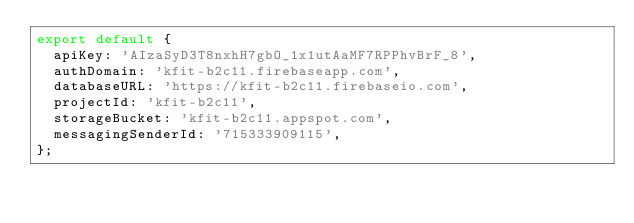<code> <loc_0><loc_0><loc_500><loc_500><_JavaScript_>export default {
  apiKey: 'AIzaSyD3T8nxhH7gbO_1x1utAaMF7RPPhvBrF_8',
  authDomain: 'kfit-b2c11.firebaseapp.com',
  databaseURL: 'https://kfit-b2c11.firebaseio.com',
  projectId: 'kfit-b2c11',
  storageBucket: 'kfit-b2c11.appspot.com',
  messagingSenderId: '715333909115',
};
</code> 